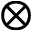Convert formula to latex. <formula><loc_0><loc_0><loc_500><loc_500>\otimes</formula> 